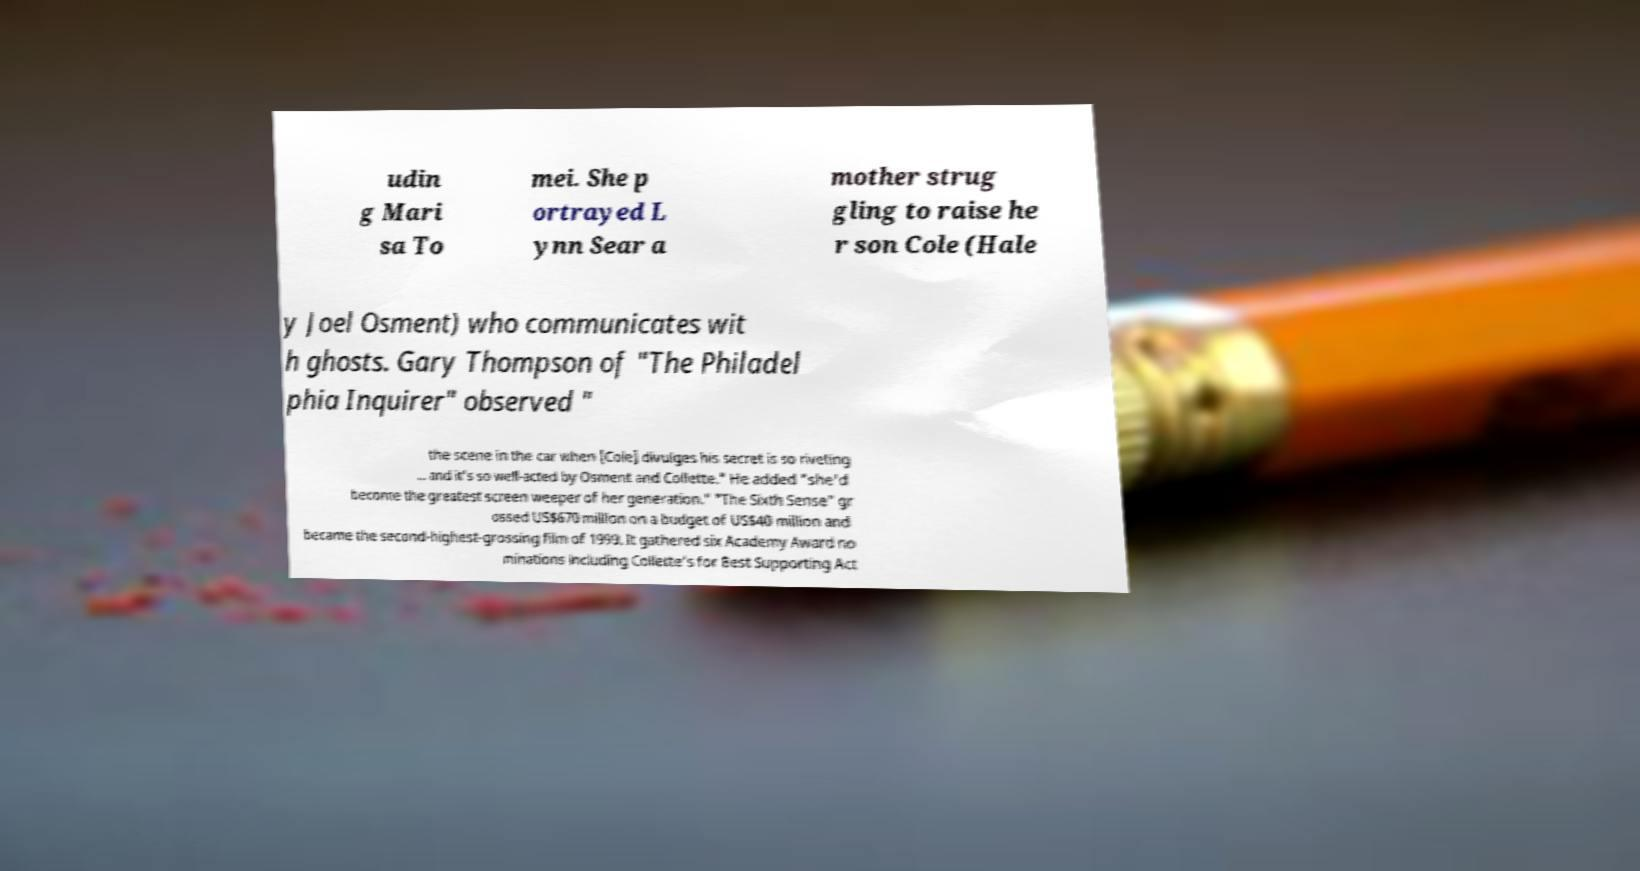For documentation purposes, I need the text within this image transcribed. Could you provide that? udin g Mari sa To mei. She p ortrayed L ynn Sear a mother strug gling to raise he r son Cole (Hale y Joel Osment) who communicates wit h ghosts. Gary Thompson of "The Philadel phia Inquirer" observed " the scene in the car when [Cole] divulges his secret is so riveting ... and it's so well-acted by Osment and Collette." He added "she'd become the greatest screen weeper of her generation." "The Sixth Sense" gr ossed US$670 million on a budget of US$40 million and became the second-highest-grossing film of 1999. It gathered six Academy Award no minations including Collette's for Best Supporting Act 